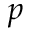<formula> <loc_0><loc_0><loc_500><loc_500>p</formula> 